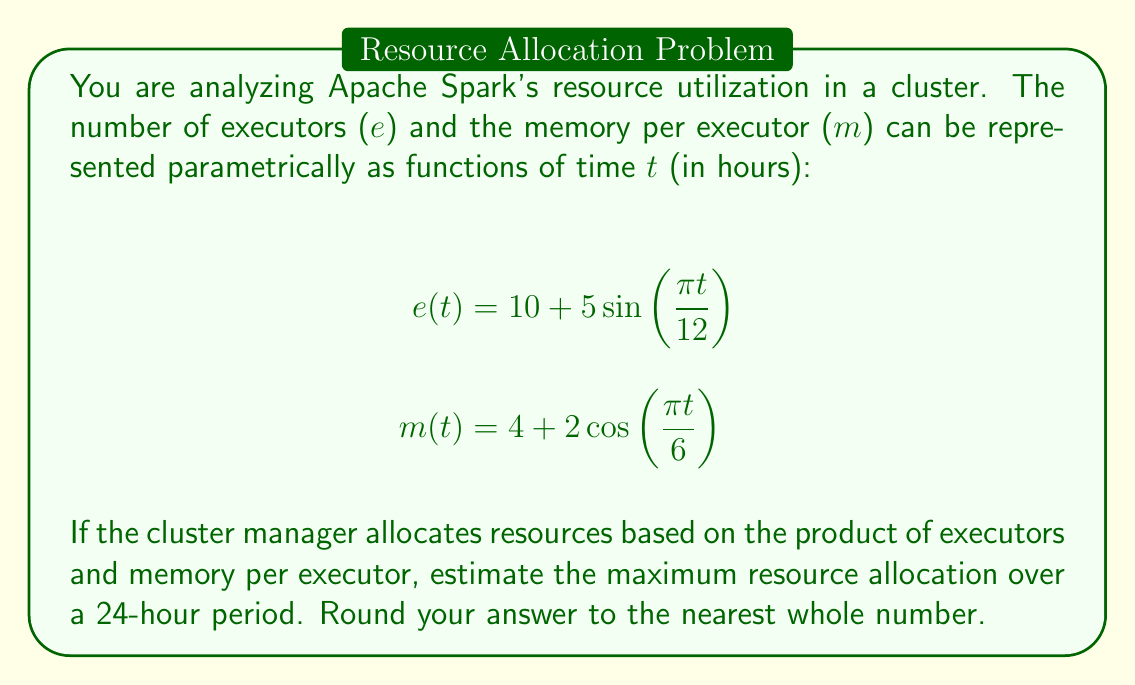Teach me how to tackle this problem. To solve this problem, we need to follow these steps:

1) The resource allocation at any time $t$ is given by the product of $e(t)$ and $m(t)$:

   $$R(t) = e(t) \cdot m(t) = (10 + 5\sin(\frac{\pi t}{12})) \cdot (4 + 2\cos(\frac{\pi t}{6}))$$

2) Expand this product:

   $$R(t) = 40 + 20\cos(\frac{\pi t}{6}) + 20\sin(\frac{\pi t}{12}) + 10\sin(\frac{\pi t}{12})\cos(\frac{\pi t}{6})$$

3) To find the maximum, we need to find the critical points where the derivative $R'(t) = 0$. However, this is a complex trigonometric equation that's difficult to solve analytically.

4) Given the periodic nature of sine and cosine functions, we can estimate the maximum by evaluating $R(t)$ at regular intervals over the 24-hour period and finding the maximum value.

5) Let's evaluate $R(t)$ at hourly intervals (t = 0, 1, 2, ..., 23):

   t = 0:  $R(0) = 40 + 20 + 0 + 0 = 60$
   t = 1:  $R(1) \approx 59.34$
   t = 2:  $R(2) \approx 57.40$
   ...
   t = 11: $R(11) \approx 59.34$
   t = 12: $R(12) = 40 - 20 + 0 + 0 = 20$
   ...
   t = 23: $R(23) \approx 59.34$

6) The maximum value among these is 60, occurring at t = 0 (and again at t = 24 due to periodicity).

7) While this method doesn't guarantee finding the absolute maximum, it provides a good estimate given the smooth nature of trigonometric functions.
Answer: 60 